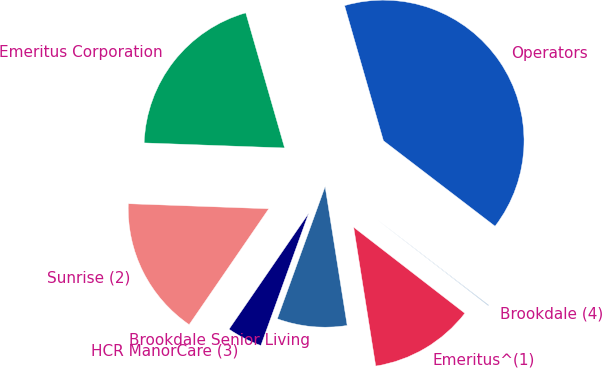Convert chart. <chart><loc_0><loc_0><loc_500><loc_500><pie_chart><fcel>Operators<fcel>Emeritus Corporation<fcel>Sunrise (2)<fcel>HCR ManorCare (3)<fcel>Brookdale Senior Living<fcel>Emeritus^(1)<fcel>Brookdale (4)<nl><fcel>39.86%<fcel>19.97%<fcel>15.99%<fcel>4.06%<fcel>8.03%<fcel>12.01%<fcel>0.08%<nl></chart> 